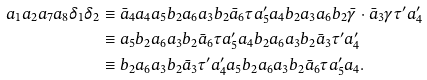<formula> <loc_0><loc_0><loc_500><loc_500>a _ { 1 } a _ { 2 } a _ { 7 } a _ { 8 } \delta _ { 1 } \delta _ { 2 } & \equiv \bar { a } _ { 4 } a _ { 4 } a _ { 5 } b _ { 2 } a _ { 6 } a _ { 3 } b _ { 2 } \bar { a } _ { 6 } \tau a ^ { \prime } _ { 5 } a _ { 4 } b _ { 2 } a _ { 3 } a _ { 6 } b _ { 2 } \bar { \gamma } \cdot \bar { a } _ { 3 } \gamma \tau ^ { \prime } a ^ { \prime } _ { 4 } \\ & \equiv a _ { 5 } b _ { 2 } a _ { 6 } a _ { 3 } b _ { 2 } \bar { a } _ { 6 } \tau a ^ { \prime } _ { 5 } a _ { 4 } b _ { 2 } a _ { 6 } a _ { 3 } b _ { 2 } \bar { a } _ { 3 } \tau ^ { \prime } a ^ { \prime } _ { 4 } \\ & \equiv b _ { 2 } a _ { 6 } a _ { 3 } b _ { 2 } \bar { a } _ { 3 } \tau ^ { \prime } a ^ { \prime } _ { 4 } a _ { 5 } b _ { 2 } a _ { 6 } a _ { 3 } b _ { 2 } \bar { a } _ { 6 } \tau a ^ { \prime } _ { 5 } a _ { 4 } .</formula> 